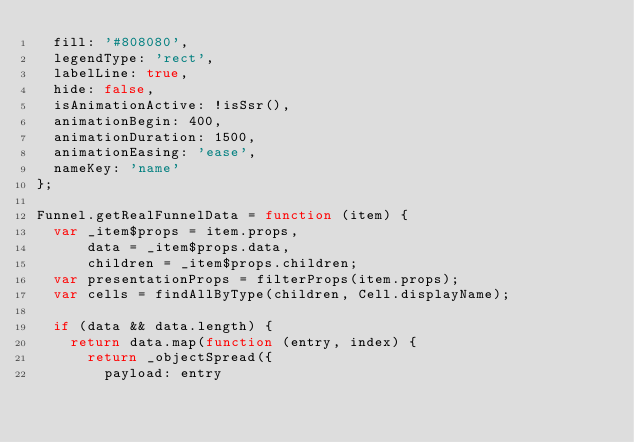Convert code to text. <code><loc_0><loc_0><loc_500><loc_500><_JavaScript_>  fill: '#808080',
  legendType: 'rect',
  labelLine: true,
  hide: false,
  isAnimationActive: !isSsr(),
  animationBegin: 400,
  animationDuration: 1500,
  animationEasing: 'ease',
  nameKey: 'name'
};

Funnel.getRealFunnelData = function (item) {
  var _item$props = item.props,
      data = _item$props.data,
      children = _item$props.children;
  var presentationProps = filterProps(item.props);
  var cells = findAllByType(children, Cell.displayName);

  if (data && data.length) {
    return data.map(function (entry, index) {
      return _objectSpread({
        payload: entry</code> 